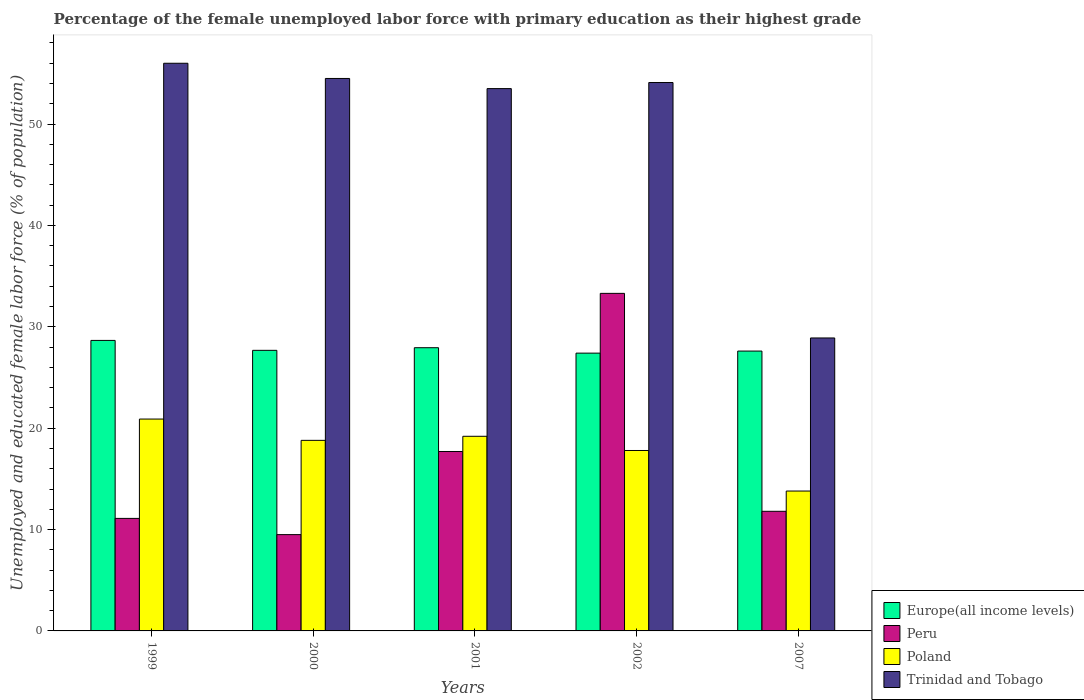How many different coloured bars are there?
Your response must be concise. 4. How many groups of bars are there?
Give a very brief answer. 5. Are the number of bars per tick equal to the number of legend labels?
Your answer should be very brief. Yes. How many bars are there on the 3rd tick from the right?
Provide a short and direct response. 4. What is the label of the 3rd group of bars from the left?
Provide a short and direct response. 2001. What is the percentage of the unemployed female labor force with primary education in Europe(all income levels) in 2001?
Offer a terse response. 27.94. Across all years, what is the maximum percentage of the unemployed female labor force with primary education in Europe(all income levels)?
Offer a terse response. 28.66. Across all years, what is the minimum percentage of the unemployed female labor force with primary education in Poland?
Your answer should be very brief. 13.8. In which year was the percentage of the unemployed female labor force with primary education in Peru maximum?
Give a very brief answer. 2002. In which year was the percentage of the unemployed female labor force with primary education in Trinidad and Tobago minimum?
Offer a very short reply. 2007. What is the total percentage of the unemployed female labor force with primary education in Peru in the graph?
Offer a terse response. 83.4. What is the difference between the percentage of the unemployed female labor force with primary education in Peru in 1999 and that in 2007?
Your answer should be compact. -0.7. What is the difference between the percentage of the unemployed female labor force with primary education in Poland in 2001 and the percentage of the unemployed female labor force with primary education in Trinidad and Tobago in 2002?
Provide a succinct answer. -34.9. What is the average percentage of the unemployed female labor force with primary education in Trinidad and Tobago per year?
Offer a terse response. 49.4. In the year 1999, what is the difference between the percentage of the unemployed female labor force with primary education in Trinidad and Tobago and percentage of the unemployed female labor force with primary education in Europe(all income levels)?
Give a very brief answer. 27.34. What is the ratio of the percentage of the unemployed female labor force with primary education in Europe(all income levels) in 2000 to that in 2002?
Offer a very short reply. 1.01. Is the percentage of the unemployed female labor force with primary education in Europe(all income levels) in 1999 less than that in 2001?
Ensure brevity in your answer.  No. Is the difference between the percentage of the unemployed female labor force with primary education in Trinidad and Tobago in 2000 and 2001 greater than the difference between the percentage of the unemployed female labor force with primary education in Europe(all income levels) in 2000 and 2001?
Make the answer very short. Yes. What is the difference between the highest and the second highest percentage of the unemployed female labor force with primary education in Europe(all income levels)?
Give a very brief answer. 0.72. What is the difference between the highest and the lowest percentage of the unemployed female labor force with primary education in Poland?
Provide a succinct answer. 7.1. Is the sum of the percentage of the unemployed female labor force with primary education in Trinidad and Tobago in 2001 and 2002 greater than the maximum percentage of the unemployed female labor force with primary education in Europe(all income levels) across all years?
Offer a terse response. Yes. How many bars are there?
Provide a succinct answer. 20. Does the graph contain any zero values?
Your answer should be very brief. No. Where does the legend appear in the graph?
Give a very brief answer. Bottom right. How many legend labels are there?
Give a very brief answer. 4. How are the legend labels stacked?
Provide a succinct answer. Vertical. What is the title of the graph?
Your response must be concise. Percentage of the female unemployed labor force with primary education as their highest grade. What is the label or title of the Y-axis?
Ensure brevity in your answer.  Unemployed and educated female labor force (% of population). What is the Unemployed and educated female labor force (% of population) of Europe(all income levels) in 1999?
Your response must be concise. 28.66. What is the Unemployed and educated female labor force (% of population) of Peru in 1999?
Ensure brevity in your answer.  11.1. What is the Unemployed and educated female labor force (% of population) of Poland in 1999?
Offer a very short reply. 20.9. What is the Unemployed and educated female labor force (% of population) in Europe(all income levels) in 2000?
Make the answer very short. 27.68. What is the Unemployed and educated female labor force (% of population) in Peru in 2000?
Your answer should be compact. 9.5. What is the Unemployed and educated female labor force (% of population) in Poland in 2000?
Give a very brief answer. 18.8. What is the Unemployed and educated female labor force (% of population) of Trinidad and Tobago in 2000?
Your answer should be compact. 54.5. What is the Unemployed and educated female labor force (% of population) in Europe(all income levels) in 2001?
Make the answer very short. 27.94. What is the Unemployed and educated female labor force (% of population) of Peru in 2001?
Your answer should be very brief. 17.7. What is the Unemployed and educated female labor force (% of population) of Poland in 2001?
Offer a terse response. 19.2. What is the Unemployed and educated female labor force (% of population) in Trinidad and Tobago in 2001?
Your response must be concise. 53.5. What is the Unemployed and educated female labor force (% of population) of Europe(all income levels) in 2002?
Your answer should be compact. 27.4. What is the Unemployed and educated female labor force (% of population) in Peru in 2002?
Offer a terse response. 33.3. What is the Unemployed and educated female labor force (% of population) in Poland in 2002?
Provide a short and direct response. 17.8. What is the Unemployed and educated female labor force (% of population) of Trinidad and Tobago in 2002?
Your answer should be very brief. 54.1. What is the Unemployed and educated female labor force (% of population) in Europe(all income levels) in 2007?
Give a very brief answer. 27.61. What is the Unemployed and educated female labor force (% of population) in Peru in 2007?
Offer a terse response. 11.8. What is the Unemployed and educated female labor force (% of population) in Poland in 2007?
Provide a succinct answer. 13.8. What is the Unemployed and educated female labor force (% of population) of Trinidad and Tobago in 2007?
Ensure brevity in your answer.  28.9. Across all years, what is the maximum Unemployed and educated female labor force (% of population) of Europe(all income levels)?
Provide a succinct answer. 28.66. Across all years, what is the maximum Unemployed and educated female labor force (% of population) of Peru?
Your answer should be compact. 33.3. Across all years, what is the maximum Unemployed and educated female labor force (% of population) in Poland?
Your response must be concise. 20.9. Across all years, what is the maximum Unemployed and educated female labor force (% of population) in Trinidad and Tobago?
Give a very brief answer. 56. Across all years, what is the minimum Unemployed and educated female labor force (% of population) in Europe(all income levels)?
Provide a succinct answer. 27.4. Across all years, what is the minimum Unemployed and educated female labor force (% of population) of Poland?
Your answer should be compact. 13.8. Across all years, what is the minimum Unemployed and educated female labor force (% of population) of Trinidad and Tobago?
Keep it short and to the point. 28.9. What is the total Unemployed and educated female labor force (% of population) in Europe(all income levels) in the graph?
Give a very brief answer. 139.29. What is the total Unemployed and educated female labor force (% of population) in Peru in the graph?
Provide a short and direct response. 83.4. What is the total Unemployed and educated female labor force (% of population) in Poland in the graph?
Provide a short and direct response. 90.5. What is the total Unemployed and educated female labor force (% of population) in Trinidad and Tobago in the graph?
Provide a succinct answer. 247. What is the difference between the Unemployed and educated female labor force (% of population) of Europe(all income levels) in 1999 and that in 2000?
Offer a very short reply. 0.98. What is the difference between the Unemployed and educated female labor force (% of population) in Poland in 1999 and that in 2000?
Ensure brevity in your answer.  2.1. What is the difference between the Unemployed and educated female labor force (% of population) of Europe(all income levels) in 1999 and that in 2001?
Your response must be concise. 0.72. What is the difference between the Unemployed and educated female labor force (% of population) of Poland in 1999 and that in 2001?
Keep it short and to the point. 1.7. What is the difference between the Unemployed and educated female labor force (% of population) of Europe(all income levels) in 1999 and that in 2002?
Keep it short and to the point. 1.25. What is the difference between the Unemployed and educated female labor force (% of population) of Peru in 1999 and that in 2002?
Provide a succinct answer. -22.2. What is the difference between the Unemployed and educated female labor force (% of population) in Trinidad and Tobago in 1999 and that in 2002?
Keep it short and to the point. 1.9. What is the difference between the Unemployed and educated female labor force (% of population) in Europe(all income levels) in 1999 and that in 2007?
Your response must be concise. 1.05. What is the difference between the Unemployed and educated female labor force (% of population) of Poland in 1999 and that in 2007?
Keep it short and to the point. 7.1. What is the difference between the Unemployed and educated female labor force (% of population) of Trinidad and Tobago in 1999 and that in 2007?
Make the answer very short. 27.1. What is the difference between the Unemployed and educated female labor force (% of population) in Europe(all income levels) in 2000 and that in 2001?
Provide a short and direct response. -0.26. What is the difference between the Unemployed and educated female labor force (% of population) in Peru in 2000 and that in 2001?
Provide a succinct answer. -8.2. What is the difference between the Unemployed and educated female labor force (% of population) in Poland in 2000 and that in 2001?
Your answer should be very brief. -0.4. What is the difference between the Unemployed and educated female labor force (% of population) of Trinidad and Tobago in 2000 and that in 2001?
Provide a succinct answer. 1. What is the difference between the Unemployed and educated female labor force (% of population) in Europe(all income levels) in 2000 and that in 2002?
Offer a terse response. 0.28. What is the difference between the Unemployed and educated female labor force (% of population) in Peru in 2000 and that in 2002?
Your answer should be compact. -23.8. What is the difference between the Unemployed and educated female labor force (% of population) in Poland in 2000 and that in 2002?
Ensure brevity in your answer.  1. What is the difference between the Unemployed and educated female labor force (% of population) of Trinidad and Tobago in 2000 and that in 2002?
Make the answer very short. 0.4. What is the difference between the Unemployed and educated female labor force (% of population) of Europe(all income levels) in 2000 and that in 2007?
Give a very brief answer. 0.07. What is the difference between the Unemployed and educated female labor force (% of population) in Peru in 2000 and that in 2007?
Make the answer very short. -2.3. What is the difference between the Unemployed and educated female labor force (% of population) in Trinidad and Tobago in 2000 and that in 2007?
Your answer should be compact. 25.6. What is the difference between the Unemployed and educated female labor force (% of population) in Europe(all income levels) in 2001 and that in 2002?
Your answer should be compact. 0.53. What is the difference between the Unemployed and educated female labor force (% of population) in Peru in 2001 and that in 2002?
Offer a terse response. -15.6. What is the difference between the Unemployed and educated female labor force (% of population) in Poland in 2001 and that in 2002?
Your response must be concise. 1.4. What is the difference between the Unemployed and educated female labor force (% of population) of Europe(all income levels) in 2001 and that in 2007?
Ensure brevity in your answer.  0.33. What is the difference between the Unemployed and educated female labor force (% of population) in Peru in 2001 and that in 2007?
Your answer should be compact. 5.9. What is the difference between the Unemployed and educated female labor force (% of population) in Poland in 2001 and that in 2007?
Keep it short and to the point. 5.4. What is the difference between the Unemployed and educated female labor force (% of population) in Trinidad and Tobago in 2001 and that in 2007?
Ensure brevity in your answer.  24.6. What is the difference between the Unemployed and educated female labor force (% of population) of Europe(all income levels) in 2002 and that in 2007?
Give a very brief answer. -0.2. What is the difference between the Unemployed and educated female labor force (% of population) of Trinidad and Tobago in 2002 and that in 2007?
Provide a succinct answer. 25.2. What is the difference between the Unemployed and educated female labor force (% of population) of Europe(all income levels) in 1999 and the Unemployed and educated female labor force (% of population) of Peru in 2000?
Keep it short and to the point. 19.16. What is the difference between the Unemployed and educated female labor force (% of population) in Europe(all income levels) in 1999 and the Unemployed and educated female labor force (% of population) in Poland in 2000?
Give a very brief answer. 9.86. What is the difference between the Unemployed and educated female labor force (% of population) of Europe(all income levels) in 1999 and the Unemployed and educated female labor force (% of population) of Trinidad and Tobago in 2000?
Make the answer very short. -25.84. What is the difference between the Unemployed and educated female labor force (% of population) of Peru in 1999 and the Unemployed and educated female labor force (% of population) of Trinidad and Tobago in 2000?
Give a very brief answer. -43.4. What is the difference between the Unemployed and educated female labor force (% of population) of Poland in 1999 and the Unemployed and educated female labor force (% of population) of Trinidad and Tobago in 2000?
Provide a succinct answer. -33.6. What is the difference between the Unemployed and educated female labor force (% of population) of Europe(all income levels) in 1999 and the Unemployed and educated female labor force (% of population) of Peru in 2001?
Offer a terse response. 10.96. What is the difference between the Unemployed and educated female labor force (% of population) in Europe(all income levels) in 1999 and the Unemployed and educated female labor force (% of population) in Poland in 2001?
Your answer should be compact. 9.46. What is the difference between the Unemployed and educated female labor force (% of population) of Europe(all income levels) in 1999 and the Unemployed and educated female labor force (% of population) of Trinidad and Tobago in 2001?
Give a very brief answer. -24.84. What is the difference between the Unemployed and educated female labor force (% of population) of Peru in 1999 and the Unemployed and educated female labor force (% of population) of Trinidad and Tobago in 2001?
Provide a short and direct response. -42.4. What is the difference between the Unemployed and educated female labor force (% of population) in Poland in 1999 and the Unemployed and educated female labor force (% of population) in Trinidad and Tobago in 2001?
Your response must be concise. -32.6. What is the difference between the Unemployed and educated female labor force (% of population) of Europe(all income levels) in 1999 and the Unemployed and educated female labor force (% of population) of Peru in 2002?
Provide a succinct answer. -4.64. What is the difference between the Unemployed and educated female labor force (% of population) of Europe(all income levels) in 1999 and the Unemployed and educated female labor force (% of population) of Poland in 2002?
Make the answer very short. 10.86. What is the difference between the Unemployed and educated female labor force (% of population) of Europe(all income levels) in 1999 and the Unemployed and educated female labor force (% of population) of Trinidad and Tobago in 2002?
Your response must be concise. -25.44. What is the difference between the Unemployed and educated female labor force (% of population) in Peru in 1999 and the Unemployed and educated female labor force (% of population) in Poland in 2002?
Your answer should be compact. -6.7. What is the difference between the Unemployed and educated female labor force (% of population) of Peru in 1999 and the Unemployed and educated female labor force (% of population) of Trinidad and Tobago in 2002?
Keep it short and to the point. -43. What is the difference between the Unemployed and educated female labor force (% of population) of Poland in 1999 and the Unemployed and educated female labor force (% of population) of Trinidad and Tobago in 2002?
Keep it short and to the point. -33.2. What is the difference between the Unemployed and educated female labor force (% of population) of Europe(all income levels) in 1999 and the Unemployed and educated female labor force (% of population) of Peru in 2007?
Ensure brevity in your answer.  16.86. What is the difference between the Unemployed and educated female labor force (% of population) of Europe(all income levels) in 1999 and the Unemployed and educated female labor force (% of population) of Poland in 2007?
Keep it short and to the point. 14.86. What is the difference between the Unemployed and educated female labor force (% of population) of Europe(all income levels) in 1999 and the Unemployed and educated female labor force (% of population) of Trinidad and Tobago in 2007?
Ensure brevity in your answer.  -0.24. What is the difference between the Unemployed and educated female labor force (% of population) in Peru in 1999 and the Unemployed and educated female labor force (% of population) in Trinidad and Tobago in 2007?
Provide a succinct answer. -17.8. What is the difference between the Unemployed and educated female labor force (% of population) of Europe(all income levels) in 2000 and the Unemployed and educated female labor force (% of population) of Peru in 2001?
Offer a very short reply. 9.98. What is the difference between the Unemployed and educated female labor force (% of population) of Europe(all income levels) in 2000 and the Unemployed and educated female labor force (% of population) of Poland in 2001?
Your answer should be compact. 8.48. What is the difference between the Unemployed and educated female labor force (% of population) of Europe(all income levels) in 2000 and the Unemployed and educated female labor force (% of population) of Trinidad and Tobago in 2001?
Offer a very short reply. -25.82. What is the difference between the Unemployed and educated female labor force (% of population) in Peru in 2000 and the Unemployed and educated female labor force (% of population) in Poland in 2001?
Keep it short and to the point. -9.7. What is the difference between the Unemployed and educated female labor force (% of population) in Peru in 2000 and the Unemployed and educated female labor force (% of population) in Trinidad and Tobago in 2001?
Give a very brief answer. -44. What is the difference between the Unemployed and educated female labor force (% of population) in Poland in 2000 and the Unemployed and educated female labor force (% of population) in Trinidad and Tobago in 2001?
Your answer should be compact. -34.7. What is the difference between the Unemployed and educated female labor force (% of population) in Europe(all income levels) in 2000 and the Unemployed and educated female labor force (% of population) in Peru in 2002?
Ensure brevity in your answer.  -5.62. What is the difference between the Unemployed and educated female labor force (% of population) in Europe(all income levels) in 2000 and the Unemployed and educated female labor force (% of population) in Poland in 2002?
Your response must be concise. 9.88. What is the difference between the Unemployed and educated female labor force (% of population) of Europe(all income levels) in 2000 and the Unemployed and educated female labor force (% of population) of Trinidad and Tobago in 2002?
Your answer should be compact. -26.42. What is the difference between the Unemployed and educated female labor force (% of population) of Peru in 2000 and the Unemployed and educated female labor force (% of population) of Poland in 2002?
Ensure brevity in your answer.  -8.3. What is the difference between the Unemployed and educated female labor force (% of population) of Peru in 2000 and the Unemployed and educated female labor force (% of population) of Trinidad and Tobago in 2002?
Ensure brevity in your answer.  -44.6. What is the difference between the Unemployed and educated female labor force (% of population) in Poland in 2000 and the Unemployed and educated female labor force (% of population) in Trinidad and Tobago in 2002?
Ensure brevity in your answer.  -35.3. What is the difference between the Unemployed and educated female labor force (% of population) in Europe(all income levels) in 2000 and the Unemployed and educated female labor force (% of population) in Peru in 2007?
Your response must be concise. 15.88. What is the difference between the Unemployed and educated female labor force (% of population) of Europe(all income levels) in 2000 and the Unemployed and educated female labor force (% of population) of Poland in 2007?
Provide a succinct answer. 13.88. What is the difference between the Unemployed and educated female labor force (% of population) of Europe(all income levels) in 2000 and the Unemployed and educated female labor force (% of population) of Trinidad and Tobago in 2007?
Give a very brief answer. -1.22. What is the difference between the Unemployed and educated female labor force (% of population) of Peru in 2000 and the Unemployed and educated female labor force (% of population) of Poland in 2007?
Your answer should be compact. -4.3. What is the difference between the Unemployed and educated female labor force (% of population) of Peru in 2000 and the Unemployed and educated female labor force (% of population) of Trinidad and Tobago in 2007?
Offer a very short reply. -19.4. What is the difference between the Unemployed and educated female labor force (% of population) of Europe(all income levels) in 2001 and the Unemployed and educated female labor force (% of population) of Peru in 2002?
Provide a succinct answer. -5.36. What is the difference between the Unemployed and educated female labor force (% of population) in Europe(all income levels) in 2001 and the Unemployed and educated female labor force (% of population) in Poland in 2002?
Your answer should be very brief. 10.14. What is the difference between the Unemployed and educated female labor force (% of population) of Europe(all income levels) in 2001 and the Unemployed and educated female labor force (% of population) of Trinidad and Tobago in 2002?
Ensure brevity in your answer.  -26.16. What is the difference between the Unemployed and educated female labor force (% of population) in Peru in 2001 and the Unemployed and educated female labor force (% of population) in Poland in 2002?
Your answer should be compact. -0.1. What is the difference between the Unemployed and educated female labor force (% of population) of Peru in 2001 and the Unemployed and educated female labor force (% of population) of Trinidad and Tobago in 2002?
Ensure brevity in your answer.  -36.4. What is the difference between the Unemployed and educated female labor force (% of population) in Poland in 2001 and the Unemployed and educated female labor force (% of population) in Trinidad and Tobago in 2002?
Offer a very short reply. -34.9. What is the difference between the Unemployed and educated female labor force (% of population) in Europe(all income levels) in 2001 and the Unemployed and educated female labor force (% of population) in Peru in 2007?
Ensure brevity in your answer.  16.14. What is the difference between the Unemployed and educated female labor force (% of population) in Europe(all income levels) in 2001 and the Unemployed and educated female labor force (% of population) in Poland in 2007?
Your answer should be compact. 14.14. What is the difference between the Unemployed and educated female labor force (% of population) in Europe(all income levels) in 2001 and the Unemployed and educated female labor force (% of population) in Trinidad and Tobago in 2007?
Your answer should be compact. -0.96. What is the difference between the Unemployed and educated female labor force (% of population) of Peru in 2001 and the Unemployed and educated female labor force (% of population) of Poland in 2007?
Offer a very short reply. 3.9. What is the difference between the Unemployed and educated female labor force (% of population) in Europe(all income levels) in 2002 and the Unemployed and educated female labor force (% of population) in Peru in 2007?
Your answer should be compact. 15.6. What is the difference between the Unemployed and educated female labor force (% of population) in Europe(all income levels) in 2002 and the Unemployed and educated female labor force (% of population) in Poland in 2007?
Keep it short and to the point. 13.6. What is the difference between the Unemployed and educated female labor force (% of population) in Europe(all income levels) in 2002 and the Unemployed and educated female labor force (% of population) in Trinidad and Tobago in 2007?
Ensure brevity in your answer.  -1.5. What is the difference between the Unemployed and educated female labor force (% of population) in Peru in 2002 and the Unemployed and educated female labor force (% of population) in Poland in 2007?
Offer a terse response. 19.5. What is the difference between the Unemployed and educated female labor force (% of population) in Peru in 2002 and the Unemployed and educated female labor force (% of population) in Trinidad and Tobago in 2007?
Provide a succinct answer. 4.4. What is the average Unemployed and educated female labor force (% of population) in Europe(all income levels) per year?
Provide a succinct answer. 27.86. What is the average Unemployed and educated female labor force (% of population) in Peru per year?
Give a very brief answer. 16.68. What is the average Unemployed and educated female labor force (% of population) of Poland per year?
Your response must be concise. 18.1. What is the average Unemployed and educated female labor force (% of population) in Trinidad and Tobago per year?
Make the answer very short. 49.4. In the year 1999, what is the difference between the Unemployed and educated female labor force (% of population) in Europe(all income levels) and Unemployed and educated female labor force (% of population) in Peru?
Your answer should be very brief. 17.56. In the year 1999, what is the difference between the Unemployed and educated female labor force (% of population) of Europe(all income levels) and Unemployed and educated female labor force (% of population) of Poland?
Offer a terse response. 7.76. In the year 1999, what is the difference between the Unemployed and educated female labor force (% of population) of Europe(all income levels) and Unemployed and educated female labor force (% of population) of Trinidad and Tobago?
Your response must be concise. -27.34. In the year 1999, what is the difference between the Unemployed and educated female labor force (% of population) of Peru and Unemployed and educated female labor force (% of population) of Trinidad and Tobago?
Your response must be concise. -44.9. In the year 1999, what is the difference between the Unemployed and educated female labor force (% of population) of Poland and Unemployed and educated female labor force (% of population) of Trinidad and Tobago?
Your answer should be very brief. -35.1. In the year 2000, what is the difference between the Unemployed and educated female labor force (% of population) in Europe(all income levels) and Unemployed and educated female labor force (% of population) in Peru?
Give a very brief answer. 18.18. In the year 2000, what is the difference between the Unemployed and educated female labor force (% of population) in Europe(all income levels) and Unemployed and educated female labor force (% of population) in Poland?
Ensure brevity in your answer.  8.88. In the year 2000, what is the difference between the Unemployed and educated female labor force (% of population) in Europe(all income levels) and Unemployed and educated female labor force (% of population) in Trinidad and Tobago?
Offer a terse response. -26.82. In the year 2000, what is the difference between the Unemployed and educated female labor force (% of population) of Peru and Unemployed and educated female labor force (% of population) of Poland?
Your response must be concise. -9.3. In the year 2000, what is the difference between the Unemployed and educated female labor force (% of population) of Peru and Unemployed and educated female labor force (% of population) of Trinidad and Tobago?
Provide a short and direct response. -45. In the year 2000, what is the difference between the Unemployed and educated female labor force (% of population) of Poland and Unemployed and educated female labor force (% of population) of Trinidad and Tobago?
Ensure brevity in your answer.  -35.7. In the year 2001, what is the difference between the Unemployed and educated female labor force (% of population) in Europe(all income levels) and Unemployed and educated female labor force (% of population) in Peru?
Your answer should be compact. 10.24. In the year 2001, what is the difference between the Unemployed and educated female labor force (% of population) in Europe(all income levels) and Unemployed and educated female labor force (% of population) in Poland?
Provide a succinct answer. 8.74. In the year 2001, what is the difference between the Unemployed and educated female labor force (% of population) in Europe(all income levels) and Unemployed and educated female labor force (% of population) in Trinidad and Tobago?
Your answer should be compact. -25.56. In the year 2001, what is the difference between the Unemployed and educated female labor force (% of population) in Peru and Unemployed and educated female labor force (% of population) in Poland?
Offer a terse response. -1.5. In the year 2001, what is the difference between the Unemployed and educated female labor force (% of population) of Peru and Unemployed and educated female labor force (% of population) of Trinidad and Tobago?
Ensure brevity in your answer.  -35.8. In the year 2001, what is the difference between the Unemployed and educated female labor force (% of population) of Poland and Unemployed and educated female labor force (% of population) of Trinidad and Tobago?
Provide a succinct answer. -34.3. In the year 2002, what is the difference between the Unemployed and educated female labor force (% of population) of Europe(all income levels) and Unemployed and educated female labor force (% of population) of Peru?
Keep it short and to the point. -5.9. In the year 2002, what is the difference between the Unemployed and educated female labor force (% of population) in Europe(all income levels) and Unemployed and educated female labor force (% of population) in Poland?
Your response must be concise. 9.6. In the year 2002, what is the difference between the Unemployed and educated female labor force (% of population) of Europe(all income levels) and Unemployed and educated female labor force (% of population) of Trinidad and Tobago?
Your answer should be very brief. -26.7. In the year 2002, what is the difference between the Unemployed and educated female labor force (% of population) of Peru and Unemployed and educated female labor force (% of population) of Poland?
Keep it short and to the point. 15.5. In the year 2002, what is the difference between the Unemployed and educated female labor force (% of population) in Peru and Unemployed and educated female labor force (% of population) in Trinidad and Tobago?
Offer a very short reply. -20.8. In the year 2002, what is the difference between the Unemployed and educated female labor force (% of population) in Poland and Unemployed and educated female labor force (% of population) in Trinidad and Tobago?
Make the answer very short. -36.3. In the year 2007, what is the difference between the Unemployed and educated female labor force (% of population) in Europe(all income levels) and Unemployed and educated female labor force (% of population) in Peru?
Your answer should be compact. 15.81. In the year 2007, what is the difference between the Unemployed and educated female labor force (% of population) in Europe(all income levels) and Unemployed and educated female labor force (% of population) in Poland?
Provide a short and direct response. 13.81. In the year 2007, what is the difference between the Unemployed and educated female labor force (% of population) of Europe(all income levels) and Unemployed and educated female labor force (% of population) of Trinidad and Tobago?
Your answer should be compact. -1.29. In the year 2007, what is the difference between the Unemployed and educated female labor force (% of population) of Peru and Unemployed and educated female labor force (% of population) of Poland?
Offer a terse response. -2. In the year 2007, what is the difference between the Unemployed and educated female labor force (% of population) of Peru and Unemployed and educated female labor force (% of population) of Trinidad and Tobago?
Your response must be concise. -17.1. In the year 2007, what is the difference between the Unemployed and educated female labor force (% of population) in Poland and Unemployed and educated female labor force (% of population) in Trinidad and Tobago?
Offer a terse response. -15.1. What is the ratio of the Unemployed and educated female labor force (% of population) of Europe(all income levels) in 1999 to that in 2000?
Your answer should be compact. 1.04. What is the ratio of the Unemployed and educated female labor force (% of population) in Peru in 1999 to that in 2000?
Your answer should be compact. 1.17. What is the ratio of the Unemployed and educated female labor force (% of population) of Poland in 1999 to that in 2000?
Offer a very short reply. 1.11. What is the ratio of the Unemployed and educated female labor force (% of population) in Trinidad and Tobago in 1999 to that in 2000?
Your response must be concise. 1.03. What is the ratio of the Unemployed and educated female labor force (% of population) of Europe(all income levels) in 1999 to that in 2001?
Ensure brevity in your answer.  1.03. What is the ratio of the Unemployed and educated female labor force (% of population) in Peru in 1999 to that in 2001?
Your answer should be compact. 0.63. What is the ratio of the Unemployed and educated female labor force (% of population) of Poland in 1999 to that in 2001?
Your response must be concise. 1.09. What is the ratio of the Unemployed and educated female labor force (% of population) of Trinidad and Tobago in 1999 to that in 2001?
Offer a very short reply. 1.05. What is the ratio of the Unemployed and educated female labor force (% of population) of Europe(all income levels) in 1999 to that in 2002?
Keep it short and to the point. 1.05. What is the ratio of the Unemployed and educated female labor force (% of population) of Poland in 1999 to that in 2002?
Keep it short and to the point. 1.17. What is the ratio of the Unemployed and educated female labor force (% of population) of Trinidad and Tobago in 1999 to that in 2002?
Give a very brief answer. 1.04. What is the ratio of the Unemployed and educated female labor force (% of population) in Europe(all income levels) in 1999 to that in 2007?
Ensure brevity in your answer.  1.04. What is the ratio of the Unemployed and educated female labor force (% of population) of Peru in 1999 to that in 2007?
Offer a very short reply. 0.94. What is the ratio of the Unemployed and educated female labor force (% of population) in Poland in 1999 to that in 2007?
Your response must be concise. 1.51. What is the ratio of the Unemployed and educated female labor force (% of population) of Trinidad and Tobago in 1999 to that in 2007?
Provide a succinct answer. 1.94. What is the ratio of the Unemployed and educated female labor force (% of population) in Peru in 2000 to that in 2001?
Ensure brevity in your answer.  0.54. What is the ratio of the Unemployed and educated female labor force (% of population) in Poland in 2000 to that in 2001?
Your answer should be compact. 0.98. What is the ratio of the Unemployed and educated female labor force (% of population) of Trinidad and Tobago in 2000 to that in 2001?
Ensure brevity in your answer.  1.02. What is the ratio of the Unemployed and educated female labor force (% of population) in Europe(all income levels) in 2000 to that in 2002?
Give a very brief answer. 1.01. What is the ratio of the Unemployed and educated female labor force (% of population) in Peru in 2000 to that in 2002?
Your answer should be compact. 0.29. What is the ratio of the Unemployed and educated female labor force (% of population) in Poland in 2000 to that in 2002?
Offer a very short reply. 1.06. What is the ratio of the Unemployed and educated female labor force (% of population) of Trinidad and Tobago in 2000 to that in 2002?
Your answer should be very brief. 1.01. What is the ratio of the Unemployed and educated female labor force (% of population) in Europe(all income levels) in 2000 to that in 2007?
Your answer should be very brief. 1. What is the ratio of the Unemployed and educated female labor force (% of population) in Peru in 2000 to that in 2007?
Ensure brevity in your answer.  0.81. What is the ratio of the Unemployed and educated female labor force (% of population) of Poland in 2000 to that in 2007?
Your response must be concise. 1.36. What is the ratio of the Unemployed and educated female labor force (% of population) of Trinidad and Tobago in 2000 to that in 2007?
Your answer should be compact. 1.89. What is the ratio of the Unemployed and educated female labor force (% of population) of Europe(all income levels) in 2001 to that in 2002?
Your answer should be very brief. 1.02. What is the ratio of the Unemployed and educated female labor force (% of population) in Peru in 2001 to that in 2002?
Your answer should be compact. 0.53. What is the ratio of the Unemployed and educated female labor force (% of population) in Poland in 2001 to that in 2002?
Keep it short and to the point. 1.08. What is the ratio of the Unemployed and educated female labor force (% of population) in Trinidad and Tobago in 2001 to that in 2002?
Offer a terse response. 0.99. What is the ratio of the Unemployed and educated female labor force (% of population) of Europe(all income levels) in 2001 to that in 2007?
Your answer should be very brief. 1.01. What is the ratio of the Unemployed and educated female labor force (% of population) in Poland in 2001 to that in 2007?
Offer a very short reply. 1.39. What is the ratio of the Unemployed and educated female labor force (% of population) of Trinidad and Tobago in 2001 to that in 2007?
Offer a terse response. 1.85. What is the ratio of the Unemployed and educated female labor force (% of population) of Europe(all income levels) in 2002 to that in 2007?
Give a very brief answer. 0.99. What is the ratio of the Unemployed and educated female labor force (% of population) of Peru in 2002 to that in 2007?
Give a very brief answer. 2.82. What is the ratio of the Unemployed and educated female labor force (% of population) of Poland in 2002 to that in 2007?
Make the answer very short. 1.29. What is the ratio of the Unemployed and educated female labor force (% of population) of Trinidad and Tobago in 2002 to that in 2007?
Make the answer very short. 1.87. What is the difference between the highest and the second highest Unemployed and educated female labor force (% of population) of Europe(all income levels)?
Give a very brief answer. 0.72. What is the difference between the highest and the second highest Unemployed and educated female labor force (% of population) of Peru?
Offer a very short reply. 15.6. What is the difference between the highest and the lowest Unemployed and educated female labor force (% of population) of Europe(all income levels)?
Your answer should be very brief. 1.25. What is the difference between the highest and the lowest Unemployed and educated female labor force (% of population) in Peru?
Provide a succinct answer. 23.8. What is the difference between the highest and the lowest Unemployed and educated female labor force (% of population) of Trinidad and Tobago?
Give a very brief answer. 27.1. 